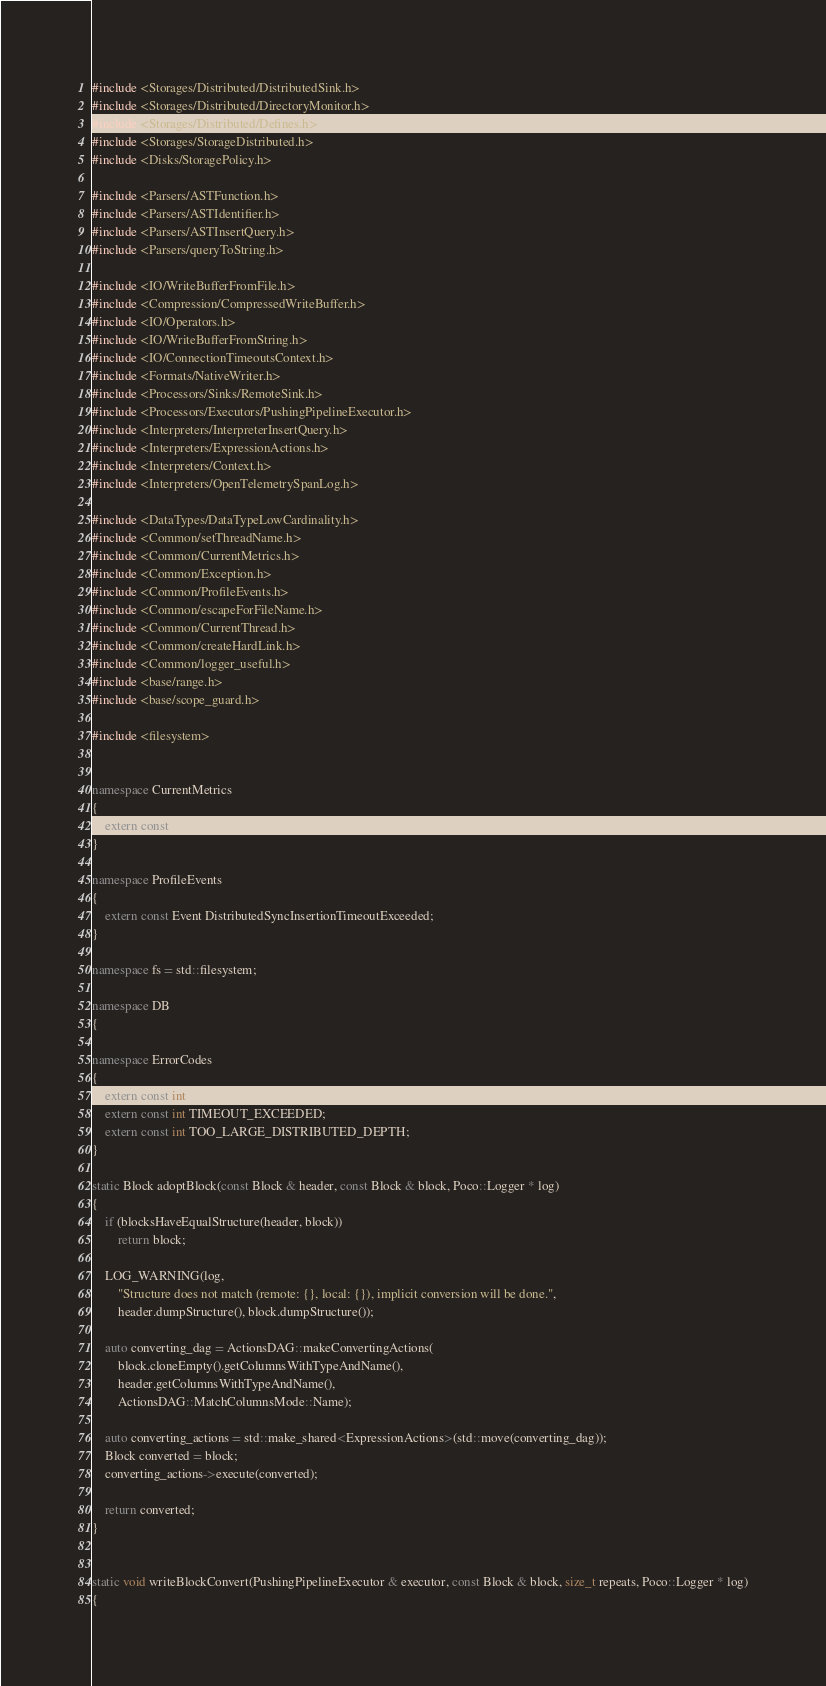Convert code to text. <code><loc_0><loc_0><loc_500><loc_500><_C++_>#include <Storages/Distributed/DistributedSink.h>
#include <Storages/Distributed/DirectoryMonitor.h>
#include <Storages/Distributed/Defines.h>
#include <Storages/StorageDistributed.h>
#include <Disks/StoragePolicy.h>

#include <Parsers/ASTFunction.h>
#include <Parsers/ASTIdentifier.h>
#include <Parsers/ASTInsertQuery.h>
#include <Parsers/queryToString.h>

#include <IO/WriteBufferFromFile.h>
#include <Compression/CompressedWriteBuffer.h>
#include <IO/Operators.h>
#include <IO/WriteBufferFromString.h>
#include <IO/ConnectionTimeoutsContext.h>
#include <Formats/NativeWriter.h>
#include <Processors/Sinks/RemoteSink.h>
#include <Processors/Executors/PushingPipelineExecutor.h>
#include <Interpreters/InterpreterInsertQuery.h>
#include <Interpreters/ExpressionActions.h>
#include <Interpreters/Context.h>
#include <Interpreters/OpenTelemetrySpanLog.h>

#include <DataTypes/DataTypeLowCardinality.h>
#include <Common/setThreadName.h>
#include <Common/CurrentMetrics.h>
#include <Common/Exception.h>
#include <Common/ProfileEvents.h>
#include <Common/escapeForFileName.h>
#include <Common/CurrentThread.h>
#include <Common/createHardLink.h>
#include <Common/logger_useful.h>
#include <base/range.h>
#include <base/scope_guard.h>

#include <filesystem>


namespace CurrentMetrics
{
    extern const Metric DistributedSend;
}

namespace ProfileEvents
{
    extern const Event DistributedSyncInsertionTimeoutExceeded;
}

namespace fs = std::filesystem;

namespace DB
{

namespace ErrorCodes
{
    extern const int LOGICAL_ERROR;
    extern const int TIMEOUT_EXCEEDED;
    extern const int TOO_LARGE_DISTRIBUTED_DEPTH;
}

static Block adoptBlock(const Block & header, const Block & block, Poco::Logger * log)
{
    if (blocksHaveEqualStructure(header, block))
        return block;

    LOG_WARNING(log,
        "Structure does not match (remote: {}, local: {}), implicit conversion will be done.",
        header.dumpStructure(), block.dumpStructure());

    auto converting_dag = ActionsDAG::makeConvertingActions(
        block.cloneEmpty().getColumnsWithTypeAndName(),
        header.getColumnsWithTypeAndName(),
        ActionsDAG::MatchColumnsMode::Name);

    auto converting_actions = std::make_shared<ExpressionActions>(std::move(converting_dag));
    Block converted = block;
    converting_actions->execute(converted);

    return converted;
}


static void writeBlockConvert(PushingPipelineExecutor & executor, const Block & block, size_t repeats, Poco::Logger * log)
{</code> 